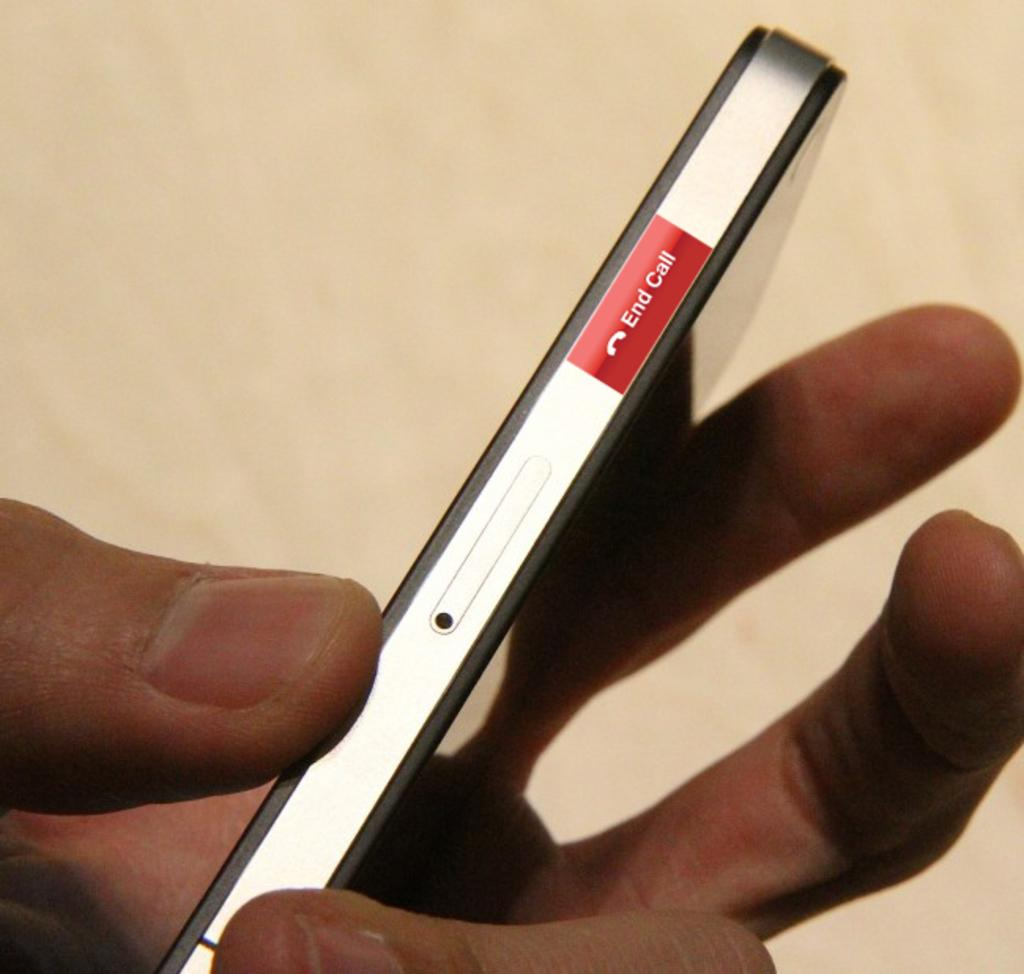<image>
Render a clear and concise summary of the photo. A man is holding a smart phone with a red message that says End Call on the side. 